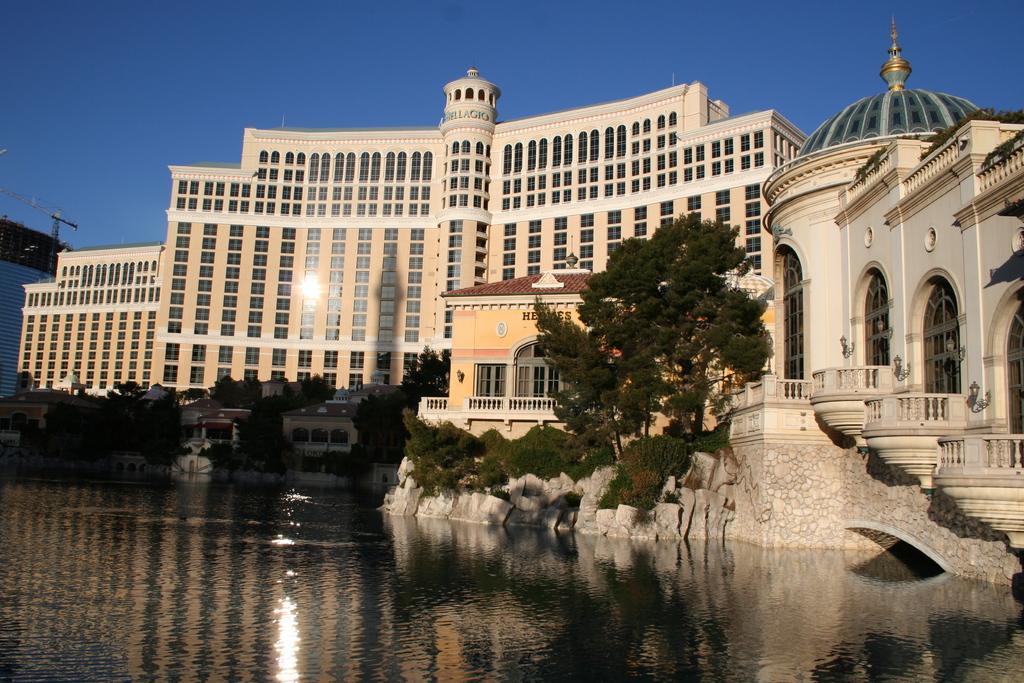In one or two sentences, can you explain what this image depicts? This image is taken outdoors. At the top of the image there is the sky. At the bottom of the image there is a pond with water. In the middle of the image there are a few buildings with walls, windows, doors and roofs. There are a few plants and trees and there are a few rocks. There is a text on the wall and there are a few railings and stairs. 